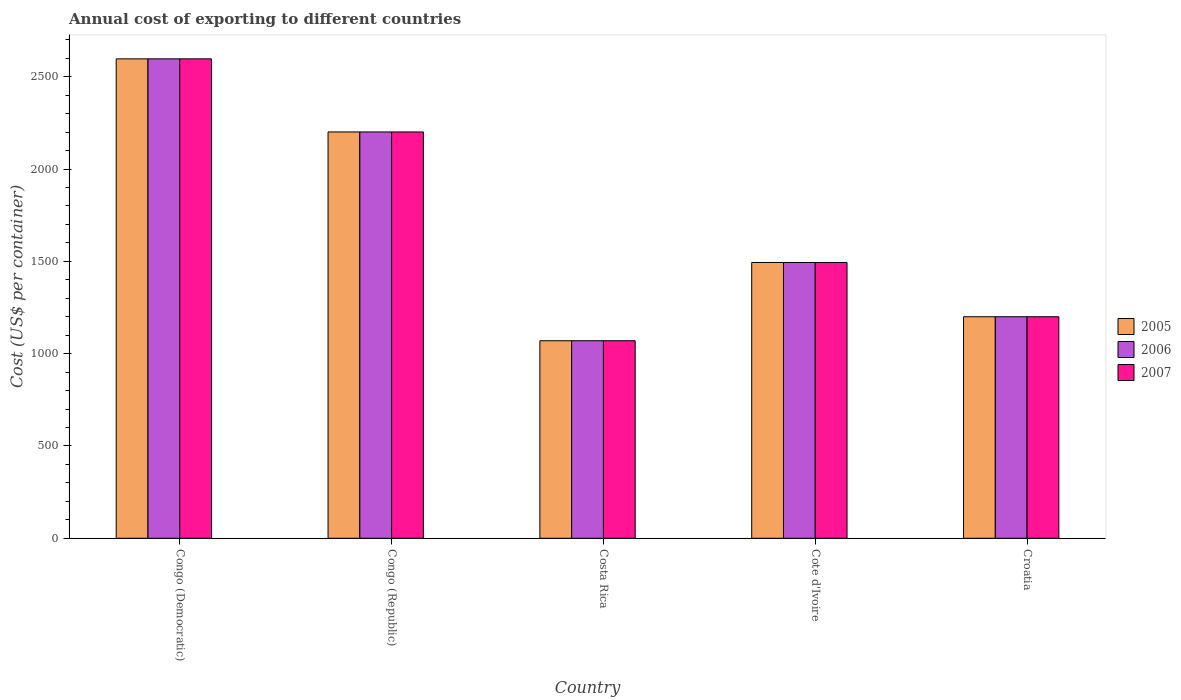How many different coloured bars are there?
Provide a short and direct response. 3. How many groups of bars are there?
Your response must be concise. 5. Are the number of bars per tick equal to the number of legend labels?
Your answer should be very brief. Yes. What is the label of the 4th group of bars from the left?
Keep it short and to the point. Cote d'Ivoire. In how many cases, is the number of bars for a given country not equal to the number of legend labels?
Your answer should be very brief. 0. What is the total annual cost of exporting in 2006 in Costa Rica?
Ensure brevity in your answer.  1070. Across all countries, what is the maximum total annual cost of exporting in 2006?
Your response must be concise. 2597. Across all countries, what is the minimum total annual cost of exporting in 2006?
Your response must be concise. 1070. In which country was the total annual cost of exporting in 2007 maximum?
Make the answer very short. Congo (Democratic). In which country was the total annual cost of exporting in 2007 minimum?
Provide a short and direct response. Costa Rica. What is the total total annual cost of exporting in 2006 in the graph?
Offer a very short reply. 8562. What is the difference between the total annual cost of exporting in 2005 in Congo (Democratic) and that in Croatia?
Provide a succinct answer. 1397. What is the difference between the total annual cost of exporting in 2007 in Costa Rica and the total annual cost of exporting in 2005 in Cote d'Ivoire?
Offer a very short reply. -424. What is the average total annual cost of exporting in 2007 per country?
Provide a succinct answer. 1712.4. What is the ratio of the total annual cost of exporting in 2005 in Congo (Democratic) to that in Congo (Republic)?
Give a very brief answer. 1.18. Is the total annual cost of exporting in 2006 in Congo (Democratic) less than that in Cote d'Ivoire?
Keep it short and to the point. No. What is the difference between the highest and the second highest total annual cost of exporting in 2006?
Provide a succinct answer. -396. What is the difference between the highest and the lowest total annual cost of exporting in 2005?
Your answer should be compact. 1527. In how many countries, is the total annual cost of exporting in 2007 greater than the average total annual cost of exporting in 2007 taken over all countries?
Your answer should be very brief. 2. Is the sum of the total annual cost of exporting in 2006 in Costa Rica and Croatia greater than the maximum total annual cost of exporting in 2007 across all countries?
Give a very brief answer. No. What does the 2nd bar from the left in Congo (Democratic) represents?
Offer a very short reply. 2006. Is it the case that in every country, the sum of the total annual cost of exporting in 2005 and total annual cost of exporting in 2007 is greater than the total annual cost of exporting in 2006?
Offer a very short reply. Yes. How many bars are there?
Ensure brevity in your answer.  15. Are all the bars in the graph horizontal?
Offer a very short reply. No. How many countries are there in the graph?
Ensure brevity in your answer.  5. Are the values on the major ticks of Y-axis written in scientific E-notation?
Your answer should be compact. No. Does the graph contain any zero values?
Ensure brevity in your answer.  No. What is the title of the graph?
Keep it short and to the point. Annual cost of exporting to different countries. Does "1973" appear as one of the legend labels in the graph?
Your answer should be very brief. No. What is the label or title of the Y-axis?
Provide a succinct answer. Cost (US$ per container). What is the Cost (US$ per container) in 2005 in Congo (Democratic)?
Give a very brief answer. 2597. What is the Cost (US$ per container) in 2006 in Congo (Democratic)?
Your answer should be compact. 2597. What is the Cost (US$ per container) in 2007 in Congo (Democratic)?
Give a very brief answer. 2597. What is the Cost (US$ per container) of 2005 in Congo (Republic)?
Ensure brevity in your answer.  2201. What is the Cost (US$ per container) in 2006 in Congo (Republic)?
Offer a terse response. 2201. What is the Cost (US$ per container) of 2007 in Congo (Republic)?
Offer a very short reply. 2201. What is the Cost (US$ per container) in 2005 in Costa Rica?
Provide a short and direct response. 1070. What is the Cost (US$ per container) of 2006 in Costa Rica?
Your response must be concise. 1070. What is the Cost (US$ per container) of 2007 in Costa Rica?
Ensure brevity in your answer.  1070. What is the Cost (US$ per container) in 2005 in Cote d'Ivoire?
Offer a very short reply. 1494. What is the Cost (US$ per container) of 2006 in Cote d'Ivoire?
Provide a short and direct response. 1494. What is the Cost (US$ per container) of 2007 in Cote d'Ivoire?
Offer a very short reply. 1494. What is the Cost (US$ per container) of 2005 in Croatia?
Give a very brief answer. 1200. What is the Cost (US$ per container) of 2006 in Croatia?
Your response must be concise. 1200. What is the Cost (US$ per container) of 2007 in Croatia?
Offer a very short reply. 1200. Across all countries, what is the maximum Cost (US$ per container) of 2005?
Offer a very short reply. 2597. Across all countries, what is the maximum Cost (US$ per container) of 2006?
Your answer should be compact. 2597. Across all countries, what is the maximum Cost (US$ per container) in 2007?
Your response must be concise. 2597. Across all countries, what is the minimum Cost (US$ per container) in 2005?
Your answer should be compact. 1070. Across all countries, what is the minimum Cost (US$ per container) in 2006?
Your response must be concise. 1070. Across all countries, what is the minimum Cost (US$ per container) of 2007?
Provide a short and direct response. 1070. What is the total Cost (US$ per container) in 2005 in the graph?
Offer a very short reply. 8562. What is the total Cost (US$ per container) in 2006 in the graph?
Your answer should be compact. 8562. What is the total Cost (US$ per container) of 2007 in the graph?
Provide a short and direct response. 8562. What is the difference between the Cost (US$ per container) of 2005 in Congo (Democratic) and that in Congo (Republic)?
Provide a short and direct response. 396. What is the difference between the Cost (US$ per container) of 2006 in Congo (Democratic) and that in Congo (Republic)?
Offer a very short reply. 396. What is the difference between the Cost (US$ per container) in 2007 in Congo (Democratic) and that in Congo (Republic)?
Give a very brief answer. 396. What is the difference between the Cost (US$ per container) in 2005 in Congo (Democratic) and that in Costa Rica?
Give a very brief answer. 1527. What is the difference between the Cost (US$ per container) of 2006 in Congo (Democratic) and that in Costa Rica?
Provide a short and direct response. 1527. What is the difference between the Cost (US$ per container) in 2007 in Congo (Democratic) and that in Costa Rica?
Offer a very short reply. 1527. What is the difference between the Cost (US$ per container) of 2005 in Congo (Democratic) and that in Cote d'Ivoire?
Give a very brief answer. 1103. What is the difference between the Cost (US$ per container) in 2006 in Congo (Democratic) and that in Cote d'Ivoire?
Ensure brevity in your answer.  1103. What is the difference between the Cost (US$ per container) in 2007 in Congo (Democratic) and that in Cote d'Ivoire?
Your answer should be very brief. 1103. What is the difference between the Cost (US$ per container) in 2005 in Congo (Democratic) and that in Croatia?
Offer a very short reply. 1397. What is the difference between the Cost (US$ per container) of 2006 in Congo (Democratic) and that in Croatia?
Offer a terse response. 1397. What is the difference between the Cost (US$ per container) in 2007 in Congo (Democratic) and that in Croatia?
Make the answer very short. 1397. What is the difference between the Cost (US$ per container) of 2005 in Congo (Republic) and that in Costa Rica?
Provide a short and direct response. 1131. What is the difference between the Cost (US$ per container) of 2006 in Congo (Republic) and that in Costa Rica?
Provide a succinct answer. 1131. What is the difference between the Cost (US$ per container) in 2007 in Congo (Republic) and that in Costa Rica?
Your response must be concise. 1131. What is the difference between the Cost (US$ per container) in 2005 in Congo (Republic) and that in Cote d'Ivoire?
Keep it short and to the point. 707. What is the difference between the Cost (US$ per container) in 2006 in Congo (Republic) and that in Cote d'Ivoire?
Ensure brevity in your answer.  707. What is the difference between the Cost (US$ per container) of 2007 in Congo (Republic) and that in Cote d'Ivoire?
Ensure brevity in your answer.  707. What is the difference between the Cost (US$ per container) in 2005 in Congo (Republic) and that in Croatia?
Your answer should be compact. 1001. What is the difference between the Cost (US$ per container) of 2006 in Congo (Republic) and that in Croatia?
Offer a very short reply. 1001. What is the difference between the Cost (US$ per container) in 2007 in Congo (Republic) and that in Croatia?
Your response must be concise. 1001. What is the difference between the Cost (US$ per container) in 2005 in Costa Rica and that in Cote d'Ivoire?
Ensure brevity in your answer.  -424. What is the difference between the Cost (US$ per container) of 2006 in Costa Rica and that in Cote d'Ivoire?
Provide a succinct answer. -424. What is the difference between the Cost (US$ per container) of 2007 in Costa Rica and that in Cote d'Ivoire?
Your response must be concise. -424. What is the difference between the Cost (US$ per container) of 2005 in Costa Rica and that in Croatia?
Give a very brief answer. -130. What is the difference between the Cost (US$ per container) in 2006 in Costa Rica and that in Croatia?
Ensure brevity in your answer.  -130. What is the difference between the Cost (US$ per container) in 2007 in Costa Rica and that in Croatia?
Give a very brief answer. -130. What is the difference between the Cost (US$ per container) in 2005 in Cote d'Ivoire and that in Croatia?
Your answer should be very brief. 294. What is the difference between the Cost (US$ per container) in 2006 in Cote d'Ivoire and that in Croatia?
Your answer should be compact. 294. What is the difference between the Cost (US$ per container) in 2007 in Cote d'Ivoire and that in Croatia?
Provide a succinct answer. 294. What is the difference between the Cost (US$ per container) of 2005 in Congo (Democratic) and the Cost (US$ per container) of 2006 in Congo (Republic)?
Offer a terse response. 396. What is the difference between the Cost (US$ per container) of 2005 in Congo (Democratic) and the Cost (US$ per container) of 2007 in Congo (Republic)?
Keep it short and to the point. 396. What is the difference between the Cost (US$ per container) in 2006 in Congo (Democratic) and the Cost (US$ per container) in 2007 in Congo (Republic)?
Keep it short and to the point. 396. What is the difference between the Cost (US$ per container) in 2005 in Congo (Democratic) and the Cost (US$ per container) in 2006 in Costa Rica?
Your response must be concise. 1527. What is the difference between the Cost (US$ per container) of 2005 in Congo (Democratic) and the Cost (US$ per container) of 2007 in Costa Rica?
Your answer should be compact. 1527. What is the difference between the Cost (US$ per container) of 2006 in Congo (Democratic) and the Cost (US$ per container) of 2007 in Costa Rica?
Give a very brief answer. 1527. What is the difference between the Cost (US$ per container) of 2005 in Congo (Democratic) and the Cost (US$ per container) of 2006 in Cote d'Ivoire?
Ensure brevity in your answer.  1103. What is the difference between the Cost (US$ per container) in 2005 in Congo (Democratic) and the Cost (US$ per container) in 2007 in Cote d'Ivoire?
Offer a terse response. 1103. What is the difference between the Cost (US$ per container) of 2006 in Congo (Democratic) and the Cost (US$ per container) of 2007 in Cote d'Ivoire?
Your answer should be compact. 1103. What is the difference between the Cost (US$ per container) in 2005 in Congo (Democratic) and the Cost (US$ per container) in 2006 in Croatia?
Your answer should be compact. 1397. What is the difference between the Cost (US$ per container) of 2005 in Congo (Democratic) and the Cost (US$ per container) of 2007 in Croatia?
Offer a terse response. 1397. What is the difference between the Cost (US$ per container) of 2006 in Congo (Democratic) and the Cost (US$ per container) of 2007 in Croatia?
Your response must be concise. 1397. What is the difference between the Cost (US$ per container) in 2005 in Congo (Republic) and the Cost (US$ per container) in 2006 in Costa Rica?
Provide a succinct answer. 1131. What is the difference between the Cost (US$ per container) in 2005 in Congo (Republic) and the Cost (US$ per container) in 2007 in Costa Rica?
Keep it short and to the point. 1131. What is the difference between the Cost (US$ per container) in 2006 in Congo (Republic) and the Cost (US$ per container) in 2007 in Costa Rica?
Provide a succinct answer. 1131. What is the difference between the Cost (US$ per container) of 2005 in Congo (Republic) and the Cost (US$ per container) of 2006 in Cote d'Ivoire?
Provide a short and direct response. 707. What is the difference between the Cost (US$ per container) in 2005 in Congo (Republic) and the Cost (US$ per container) in 2007 in Cote d'Ivoire?
Offer a very short reply. 707. What is the difference between the Cost (US$ per container) in 2006 in Congo (Republic) and the Cost (US$ per container) in 2007 in Cote d'Ivoire?
Your answer should be very brief. 707. What is the difference between the Cost (US$ per container) of 2005 in Congo (Republic) and the Cost (US$ per container) of 2006 in Croatia?
Your answer should be very brief. 1001. What is the difference between the Cost (US$ per container) in 2005 in Congo (Republic) and the Cost (US$ per container) in 2007 in Croatia?
Your response must be concise. 1001. What is the difference between the Cost (US$ per container) in 2006 in Congo (Republic) and the Cost (US$ per container) in 2007 in Croatia?
Offer a terse response. 1001. What is the difference between the Cost (US$ per container) in 2005 in Costa Rica and the Cost (US$ per container) in 2006 in Cote d'Ivoire?
Provide a succinct answer. -424. What is the difference between the Cost (US$ per container) in 2005 in Costa Rica and the Cost (US$ per container) in 2007 in Cote d'Ivoire?
Offer a very short reply. -424. What is the difference between the Cost (US$ per container) in 2006 in Costa Rica and the Cost (US$ per container) in 2007 in Cote d'Ivoire?
Ensure brevity in your answer.  -424. What is the difference between the Cost (US$ per container) in 2005 in Costa Rica and the Cost (US$ per container) in 2006 in Croatia?
Give a very brief answer. -130. What is the difference between the Cost (US$ per container) in 2005 in Costa Rica and the Cost (US$ per container) in 2007 in Croatia?
Provide a short and direct response. -130. What is the difference between the Cost (US$ per container) of 2006 in Costa Rica and the Cost (US$ per container) of 2007 in Croatia?
Make the answer very short. -130. What is the difference between the Cost (US$ per container) in 2005 in Cote d'Ivoire and the Cost (US$ per container) in 2006 in Croatia?
Ensure brevity in your answer.  294. What is the difference between the Cost (US$ per container) of 2005 in Cote d'Ivoire and the Cost (US$ per container) of 2007 in Croatia?
Your answer should be compact. 294. What is the difference between the Cost (US$ per container) in 2006 in Cote d'Ivoire and the Cost (US$ per container) in 2007 in Croatia?
Offer a very short reply. 294. What is the average Cost (US$ per container) in 2005 per country?
Give a very brief answer. 1712.4. What is the average Cost (US$ per container) in 2006 per country?
Ensure brevity in your answer.  1712.4. What is the average Cost (US$ per container) in 2007 per country?
Offer a terse response. 1712.4. What is the difference between the Cost (US$ per container) of 2005 and Cost (US$ per container) of 2006 in Congo (Democratic)?
Keep it short and to the point. 0. What is the difference between the Cost (US$ per container) in 2006 and Cost (US$ per container) in 2007 in Congo (Democratic)?
Keep it short and to the point. 0. What is the difference between the Cost (US$ per container) of 2005 and Cost (US$ per container) of 2007 in Congo (Republic)?
Make the answer very short. 0. What is the difference between the Cost (US$ per container) of 2006 and Cost (US$ per container) of 2007 in Congo (Republic)?
Your response must be concise. 0. What is the difference between the Cost (US$ per container) in 2005 and Cost (US$ per container) in 2006 in Costa Rica?
Your answer should be compact. 0. What is the difference between the Cost (US$ per container) in 2005 and Cost (US$ per container) in 2007 in Costa Rica?
Keep it short and to the point. 0. What is the difference between the Cost (US$ per container) of 2005 and Cost (US$ per container) of 2007 in Cote d'Ivoire?
Give a very brief answer. 0. What is the difference between the Cost (US$ per container) in 2006 and Cost (US$ per container) in 2007 in Cote d'Ivoire?
Ensure brevity in your answer.  0. What is the difference between the Cost (US$ per container) in 2005 and Cost (US$ per container) in 2006 in Croatia?
Make the answer very short. 0. What is the difference between the Cost (US$ per container) of 2005 and Cost (US$ per container) of 2007 in Croatia?
Offer a terse response. 0. What is the ratio of the Cost (US$ per container) in 2005 in Congo (Democratic) to that in Congo (Republic)?
Offer a terse response. 1.18. What is the ratio of the Cost (US$ per container) in 2006 in Congo (Democratic) to that in Congo (Republic)?
Make the answer very short. 1.18. What is the ratio of the Cost (US$ per container) in 2007 in Congo (Democratic) to that in Congo (Republic)?
Give a very brief answer. 1.18. What is the ratio of the Cost (US$ per container) of 2005 in Congo (Democratic) to that in Costa Rica?
Offer a terse response. 2.43. What is the ratio of the Cost (US$ per container) in 2006 in Congo (Democratic) to that in Costa Rica?
Make the answer very short. 2.43. What is the ratio of the Cost (US$ per container) in 2007 in Congo (Democratic) to that in Costa Rica?
Your answer should be very brief. 2.43. What is the ratio of the Cost (US$ per container) of 2005 in Congo (Democratic) to that in Cote d'Ivoire?
Give a very brief answer. 1.74. What is the ratio of the Cost (US$ per container) in 2006 in Congo (Democratic) to that in Cote d'Ivoire?
Your answer should be very brief. 1.74. What is the ratio of the Cost (US$ per container) of 2007 in Congo (Democratic) to that in Cote d'Ivoire?
Keep it short and to the point. 1.74. What is the ratio of the Cost (US$ per container) in 2005 in Congo (Democratic) to that in Croatia?
Make the answer very short. 2.16. What is the ratio of the Cost (US$ per container) of 2006 in Congo (Democratic) to that in Croatia?
Make the answer very short. 2.16. What is the ratio of the Cost (US$ per container) of 2007 in Congo (Democratic) to that in Croatia?
Your response must be concise. 2.16. What is the ratio of the Cost (US$ per container) of 2005 in Congo (Republic) to that in Costa Rica?
Provide a short and direct response. 2.06. What is the ratio of the Cost (US$ per container) in 2006 in Congo (Republic) to that in Costa Rica?
Your answer should be very brief. 2.06. What is the ratio of the Cost (US$ per container) in 2007 in Congo (Republic) to that in Costa Rica?
Make the answer very short. 2.06. What is the ratio of the Cost (US$ per container) in 2005 in Congo (Republic) to that in Cote d'Ivoire?
Your answer should be compact. 1.47. What is the ratio of the Cost (US$ per container) in 2006 in Congo (Republic) to that in Cote d'Ivoire?
Give a very brief answer. 1.47. What is the ratio of the Cost (US$ per container) of 2007 in Congo (Republic) to that in Cote d'Ivoire?
Your response must be concise. 1.47. What is the ratio of the Cost (US$ per container) in 2005 in Congo (Republic) to that in Croatia?
Offer a very short reply. 1.83. What is the ratio of the Cost (US$ per container) in 2006 in Congo (Republic) to that in Croatia?
Offer a terse response. 1.83. What is the ratio of the Cost (US$ per container) of 2007 in Congo (Republic) to that in Croatia?
Provide a short and direct response. 1.83. What is the ratio of the Cost (US$ per container) in 2005 in Costa Rica to that in Cote d'Ivoire?
Make the answer very short. 0.72. What is the ratio of the Cost (US$ per container) of 2006 in Costa Rica to that in Cote d'Ivoire?
Give a very brief answer. 0.72. What is the ratio of the Cost (US$ per container) in 2007 in Costa Rica to that in Cote d'Ivoire?
Your answer should be very brief. 0.72. What is the ratio of the Cost (US$ per container) of 2005 in Costa Rica to that in Croatia?
Offer a terse response. 0.89. What is the ratio of the Cost (US$ per container) of 2006 in Costa Rica to that in Croatia?
Make the answer very short. 0.89. What is the ratio of the Cost (US$ per container) in 2007 in Costa Rica to that in Croatia?
Keep it short and to the point. 0.89. What is the ratio of the Cost (US$ per container) in 2005 in Cote d'Ivoire to that in Croatia?
Offer a very short reply. 1.25. What is the ratio of the Cost (US$ per container) of 2006 in Cote d'Ivoire to that in Croatia?
Your response must be concise. 1.25. What is the ratio of the Cost (US$ per container) of 2007 in Cote d'Ivoire to that in Croatia?
Ensure brevity in your answer.  1.25. What is the difference between the highest and the second highest Cost (US$ per container) in 2005?
Your answer should be compact. 396. What is the difference between the highest and the second highest Cost (US$ per container) of 2006?
Make the answer very short. 396. What is the difference between the highest and the second highest Cost (US$ per container) in 2007?
Provide a succinct answer. 396. What is the difference between the highest and the lowest Cost (US$ per container) of 2005?
Offer a very short reply. 1527. What is the difference between the highest and the lowest Cost (US$ per container) of 2006?
Your answer should be compact. 1527. What is the difference between the highest and the lowest Cost (US$ per container) of 2007?
Your answer should be compact. 1527. 